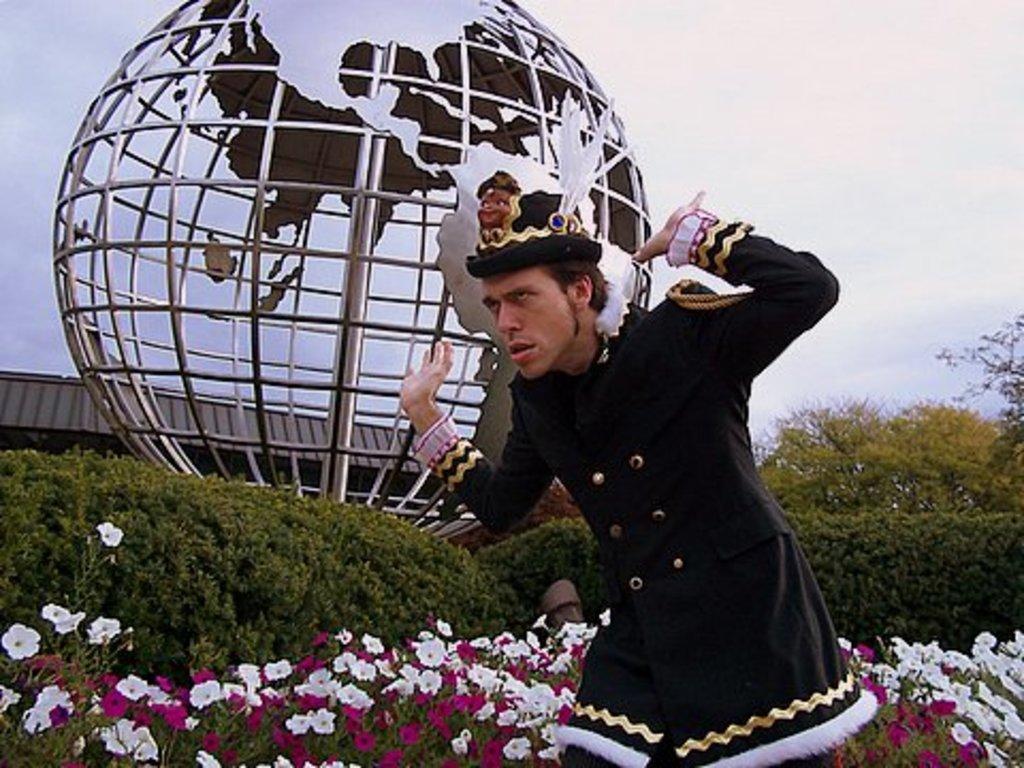Could you give a brief overview of what you see in this image? In the image there is a man he is giving a different expression and pose, behind him there are flower plants, trees and there is a sculpture of a globe in the background. 